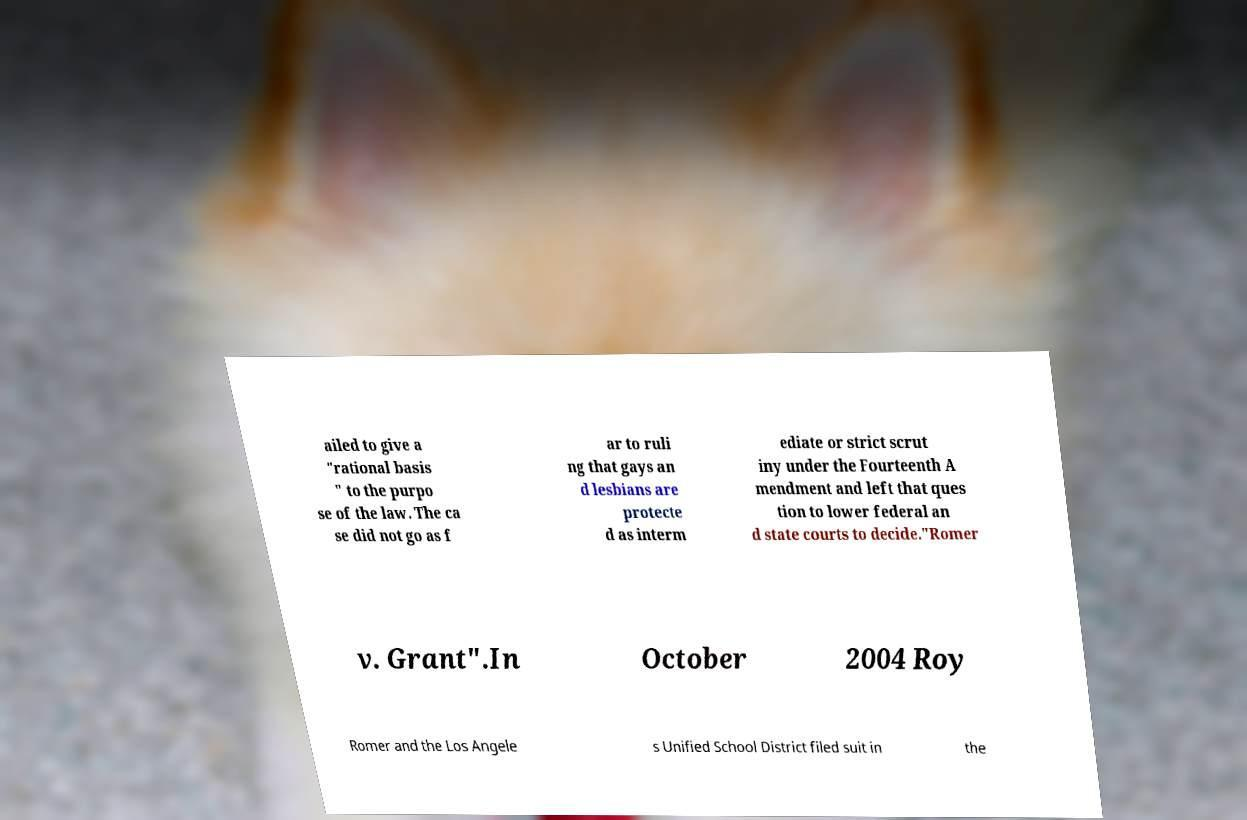Please read and relay the text visible in this image. What does it say? ailed to give a "rational basis " to the purpo se of the law. The ca se did not go as f ar to ruli ng that gays an d lesbians are protecte d as interm ediate or strict scrut iny under the Fourteenth A mendment and left that ques tion to lower federal an d state courts to decide."Romer v. Grant".In October 2004 Roy Romer and the Los Angele s Unified School District filed suit in the 